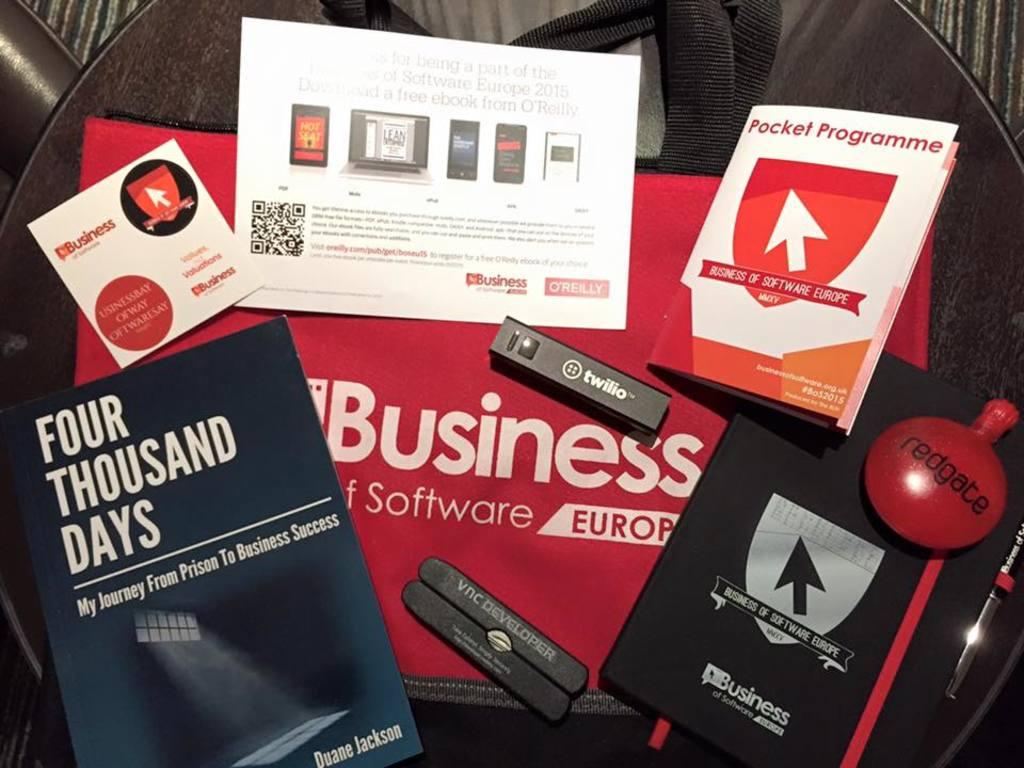What does the white sing say?
Your answer should be very brief. Unanswerable. 